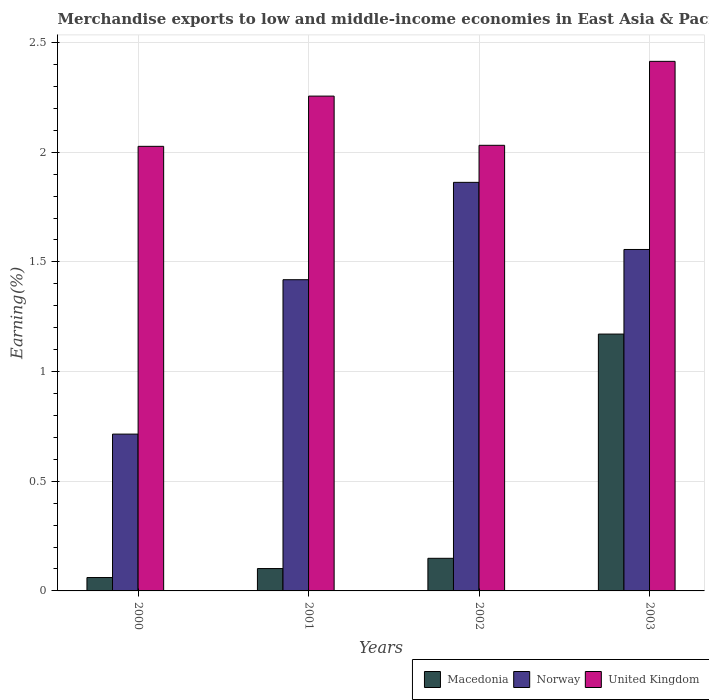Are the number of bars on each tick of the X-axis equal?
Make the answer very short. Yes. What is the percentage of amount earned from merchandise exports in Norway in 2001?
Make the answer very short. 1.42. Across all years, what is the maximum percentage of amount earned from merchandise exports in Norway?
Your answer should be very brief. 1.86. Across all years, what is the minimum percentage of amount earned from merchandise exports in Macedonia?
Provide a short and direct response. 0.06. What is the total percentage of amount earned from merchandise exports in Macedonia in the graph?
Provide a short and direct response. 1.48. What is the difference between the percentage of amount earned from merchandise exports in United Kingdom in 2001 and that in 2003?
Give a very brief answer. -0.16. What is the difference between the percentage of amount earned from merchandise exports in Macedonia in 2001 and the percentage of amount earned from merchandise exports in Norway in 2002?
Ensure brevity in your answer.  -1.76. What is the average percentage of amount earned from merchandise exports in United Kingdom per year?
Your answer should be very brief. 2.18. In the year 2000, what is the difference between the percentage of amount earned from merchandise exports in Norway and percentage of amount earned from merchandise exports in United Kingdom?
Your answer should be compact. -1.31. In how many years, is the percentage of amount earned from merchandise exports in Macedonia greater than 1.6 %?
Keep it short and to the point. 0. What is the ratio of the percentage of amount earned from merchandise exports in United Kingdom in 2000 to that in 2003?
Your response must be concise. 0.84. Is the percentage of amount earned from merchandise exports in United Kingdom in 2000 less than that in 2002?
Ensure brevity in your answer.  Yes. Is the difference between the percentage of amount earned from merchandise exports in Norway in 2000 and 2003 greater than the difference between the percentage of amount earned from merchandise exports in United Kingdom in 2000 and 2003?
Offer a very short reply. No. What is the difference between the highest and the second highest percentage of amount earned from merchandise exports in Norway?
Your answer should be very brief. 0.31. What is the difference between the highest and the lowest percentage of amount earned from merchandise exports in United Kingdom?
Offer a terse response. 0.39. In how many years, is the percentage of amount earned from merchandise exports in Norway greater than the average percentage of amount earned from merchandise exports in Norway taken over all years?
Keep it short and to the point. 3. Is the sum of the percentage of amount earned from merchandise exports in Norway in 2000 and 2002 greater than the maximum percentage of amount earned from merchandise exports in United Kingdom across all years?
Provide a short and direct response. Yes. What does the 2nd bar from the left in 2003 represents?
Your response must be concise. Norway. What does the 3rd bar from the right in 2000 represents?
Offer a terse response. Macedonia. Is it the case that in every year, the sum of the percentage of amount earned from merchandise exports in Macedonia and percentage of amount earned from merchandise exports in United Kingdom is greater than the percentage of amount earned from merchandise exports in Norway?
Offer a very short reply. Yes. Are all the bars in the graph horizontal?
Your answer should be very brief. No. Are the values on the major ticks of Y-axis written in scientific E-notation?
Your answer should be compact. No. Does the graph contain any zero values?
Keep it short and to the point. No. Where does the legend appear in the graph?
Your answer should be very brief. Bottom right. How many legend labels are there?
Your response must be concise. 3. What is the title of the graph?
Your response must be concise. Merchandise exports to low and middle-income economies in East Asia & Pacific. What is the label or title of the X-axis?
Give a very brief answer. Years. What is the label or title of the Y-axis?
Your answer should be compact. Earning(%). What is the Earning(%) in Macedonia in 2000?
Provide a short and direct response. 0.06. What is the Earning(%) of Norway in 2000?
Offer a terse response. 0.71. What is the Earning(%) in United Kingdom in 2000?
Keep it short and to the point. 2.03. What is the Earning(%) in Macedonia in 2001?
Ensure brevity in your answer.  0.1. What is the Earning(%) of Norway in 2001?
Provide a short and direct response. 1.42. What is the Earning(%) in United Kingdom in 2001?
Give a very brief answer. 2.26. What is the Earning(%) in Macedonia in 2002?
Your answer should be compact. 0.15. What is the Earning(%) of Norway in 2002?
Your answer should be very brief. 1.86. What is the Earning(%) of United Kingdom in 2002?
Your answer should be compact. 2.03. What is the Earning(%) of Macedonia in 2003?
Your answer should be compact. 1.17. What is the Earning(%) in Norway in 2003?
Provide a succinct answer. 1.56. What is the Earning(%) in United Kingdom in 2003?
Ensure brevity in your answer.  2.41. Across all years, what is the maximum Earning(%) in Macedonia?
Offer a very short reply. 1.17. Across all years, what is the maximum Earning(%) of Norway?
Your response must be concise. 1.86. Across all years, what is the maximum Earning(%) in United Kingdom?
Offer a very short reply. 2.41. Across all years, what is the minimum Earning(%) in Macedonia?
Provide a short and direct response. 0.06. Across all years, what is the minimum Earning(%) of Norway?
Offer a very short reply. 0.71. Across all years, what is the minimum Earning(%) of United Kingdom?
Offer a terse response. 2.03. What is the total Earning(%) in Macedonia in the graph?
Make the answer very short. 1.48. What is the total Earning(%) in Norway in the graph?
Give a very brief answer. 5.55. What is the total Earning(%) in United Kingdom in the graph?
Offer a very short reply. 8.73. What is the difference between the Earning(%) of Macedonia in 2000 and that in 2001?
Your answer should be very brief. -0.04. What is the difference between the Earning(%) in Norway in 2000 and that in 2001?
Provide a short and direct response. -0.7. What is the difference between the Earning(%) in United Kingdom in 2000 and that in 2001?
Your response must be concise. -0.23. What is the difference between the Earning(%) of Macedonia in 2000 and that in 2002?
Provide a succinct answer. -0.09. What is the difference between the Earning(%) in Norway in 2000 and that in 2002?
Ensure brevity in your answer.  -1.15. What is the difference between the Earning(%) of United Kingdom in 2000 and that in 2002?
Your response must be concise. -0. What is the difference between the Earning(%) of Macedonia in 2000 and that in 2003?
Your answer should be compact. -1.11. What is the difference between the Earning(%) of Norway in 2000 and that in 2003?
Ensure brevity in your answer.  -0.84. What is the difference between the Earning(%) in United Kingdom in 2000 and that in 2003?
Provide a short and direct response. -0.39. What is the difference between the Earning(%) in Macedonia in 2001 and that in 2002?
Your response must be concise. -0.05. What is the difference between the Earning(%) of Norway in 2001 and that in 2002?
Your response must be concise. -0.44. What is the difference between the Earning(%) in United Kingdom in 2001 and that in 2002?
Give a very brief answer. 0.22. What is the difference between the Earning(%) of Macedonia in 2001 and that in 2003?
Your answer should be compact. -1.07. What is the difference between the Earning(%) of Norway in 2001 and that in 2003?
Your response must be concise. -0.14. What is the difference between the Earning(%) in United Kingdom in 2001 and that in 2003?
Keep it short and to the point. -0.16. What is the difference between the Earning(%) in Macedonia in 2002 and that in 2003?
Ensure brevity in your answer.  -1.02. What is the difference between the Earning(%) of Norway in 2002 and that in 2003?
Make the answer very short. 0.31. What is the difference between the Earning(%) of United Kingdom in 2002 and that in 2003?
Provide a succinct answer. -0.38. What is the difference between the Earning(%) of Macedonia in 2000 and the Earning(%) of Norway in 2001?
Your answer should be compact. -1.36. What is the difference between the Earning(%) of Macedonia in 2000 and the Earning(%) of United Kingdom in 2001?
Ensure brevity in your answer.  -2.19. What is the difference between the Earning(%) of Norway in 2000 and the Earning(%) of United Kingdom in 2001?
Make the answer very short. -1.54. What is the difference between the Earning(%) of Macedonia in 2000 and the Earning(%) of Norway in 2002?
Give a very brief answer. -1.8. What is the difference between the Earning(%) of Macedonia in 2000 and the Earning(%) of United Kingdom in 2002?
Offer a very short reply. -1.97. What is the difference between the Earning(%) in Norway in 2000 and the Earning(%) in United Kingdom in 2002?
Keep it short and to the point. -1.32. What is the difference between the Earning(%) of Macedonia in 2000 and the Earning(%) of Norway in 2003?
Keep it short and to the point. -1.5. What is the difference between the Earning(%) in Macedonia in 2000 and the Earning(%) in United Kingdom in 2003?
Your response must be concise. -2.35. What is the difference between the Earning(%) of Norway in 2000 and the Earning(%) of United Kingdom in 2003?
Your response must be concise. -1.7. What is the difference between the Earning(%) of Macedonia in 2001 and the Earning(%) of Norway in 2002?
Provide a succinct answer. -1.76. What is the difference between the Earning(%) of Macedonia in 2001 and the Earning(%) of United Kingdom in 2002?
Offer a terse response. -1.93. What is the difference between the Earning(%) in Norway in 2001 and the Earning(%) in United Kingdom in 2002?
Ensure brevity in your answer.  -0.61. What is the difference between the Earning(%) of Macedonia in 2001 and the Earning(%) of Norway in 2003?
Offer a terse response. -1.45. What is the difference between the Earning(%) in Macedonia in 2001 and the Earning(%) in United Kingdom in 2003?
Keep it short and to the point. -2.31. What is the difference between the Earning(%) of Norway in 2001 and the Earning(%) of United Kingdom in 2003?
Make the answer very short. -1. What is the difference between the Earning(%) of Macedonia in 2002 and the Earning(%) of Norway in 2003?
Provide a short and direct response. -1.41. What is the difference between the Earning(%) in Macedonia in 2002 and the Earning(%) in United Kingdom in 2003?
Make the answer very short. -2.27. What is the difference between the Earning(%) in Norway in 2002 and the Earning(%) in United Kingdom in 2003?
Give a very brief answer. -0.55. What is the average Earning(%) in Macedonia per year?
Give a very brief answer. 0.37. What is the average Earning(%) of Norway per year?
Your answer should be compact. 1.39. What is the average Earning(%) in United Kingdom per year?
Your response must be concise. 2.18. In the year 2000, what is the difference between the Earning(%) in Macedonia and Earning(%) in Norway?
Your answer should be compact. -0.65. In the year 2000, what is the difference between the Earning(%) of Macedonia and Earning(%) of United Kingdom?
Keep it short and to the point. -1.97. In the year 2000, what is the difference between the Earning(%) in Norway and Earning(%) in United Kingdom?
Your answer should be very brief. -1.31. In the year 2001, what is the difference between the Earning(%) in Macedonia and Earning(%) in Norway?
Your answer should be very brief. -1.32. In the year 2001, what is the difference between the Earning(%) of Macedonia and Earning(%) of United Kingdom?
Make the answer very short. -2.15. In the year 2001, what is the difference between the Earning(%) in Norway and Earning(%) in United Kingdom?
Keep it short and to the point. -0.84. In the year 2002, what is the difference between the Earning(%) of Macedonia and Earning(%) of Norway?
Your answer should be very brief. -1.71. In the year 2002, what is the difference between the Earning(%) of Macedonia and Earning(%) of United Kingdom?
Keep it short and to the point. -1.88. In the year 2002, what is the difference between the Earning(%) of Norway and Earning(%) of United Kingdom?
Keep it short and to the point. -0.17. In the year 2003, what is the difference between the Earning(%) in Macedonia and Earning(%) in Norway?
Make the answer very short. -0.39. In the year 2003, what is the difference between the Earning(%) in Macedonia and Earning(%) in United Kingdom?
Ensure brevity in your answer.  -1.24. In the year 2003, what is the difference between the Earning(%) of Norway and Earning(%) of United Kingdom?
Make the answer very short. -0.86. What is the ratio of the Earning(%) in Macedonia in 2000 to that in 2001?
Your response must be concise. 0.6. What is the ratio of the Earning(%) in Norway in 2000 to that in 2001?
Your response must be concise. 0.5. What is the ratio of the Earning(%) in United Kingdom in 2000 to that in 2001?
Your response must be concise. 0.9. What is the ratio of the Earning(%) in Macedonia in 2000 to that in 2002?
Give a very brief answer. 0.41. What is the ratio of the Earning(%) in Norway in 2000 to that in 2002?
Ensure brevity in your answer.  0.38. What is the ratio of the Earning(%) of United Kingdom in 2000 to that in 2002?
Your response must be concise. 1. What is the ratio of the Earning(%) in Macedonia in 2000 to that in 2003?
Ensure brevity in your answer.  0.05. What is the ratio of the Earning(%) of Norway in 2000 to that in 2003?
Your answer should be very brief. 0.46. What is the ratio of the Earning(%) in United Kingdom in 2000 to that in 2003?
Ensure brevity in your answer.  0.84. What is the ratio of the Earning(%) in Macedonia in 2001 to that in 2002?
Offer a very short reply. 0.69. What is the ratio of the Earning(%) of Norway in 2001 to that in 2002?
Offer a terse response. 0.76. What is the ratio of the Earning(%) of United Kingdom in 2001 to that in 2002?
Your response must be concise. 1.11. What is the ratio of the Earning(%) of Macedonia in 2001 to that in 2003?
Provide a short and direct response. 0.09. What is the ratio of the Earning(%) in Norway in 2001 to that in 2003?
Your answer should be compact. 0.91. What is the ratio of the Earning(%) of United Kingdom in 2001 to that in 2003?
Your answer should be very brief. 0.93. What is the ratio of the Earning(%) in Macedonia in 2002 to that in 2003?
Offer a terse response. 0.13. What is the ratio of the Earning(%) in Norway in 2002 to that in 2003?
Make the answer very short. 1.2. What is the ratio of the Earning(%) of United Kingdom in 2002 to that in 2003?
Offer a very short reply. 0.84. What is the difference between the highest and the second highest Earning(%) of Macedonia?
Your response must be concise. 1.02. What is the difference between the highest and the second highest Earning(%) of Norway?
Offer a terse response. 0.31. What is the difference between the highest and the second highest Earning(%) of United Kingdom?
Keep it short and to the point. 0.16. What is the difference between the highest and the lowest Earning(%) of Macedonia?
Offer a terse response. 1.11. What is the difference between the highest and the lowest Earning(%) in Norway?
Give a very brief answer. 1.15. What is the difference between the highest and the lowest Earning(%) of United Kingdom?
Your response must be concise. 0.39. 